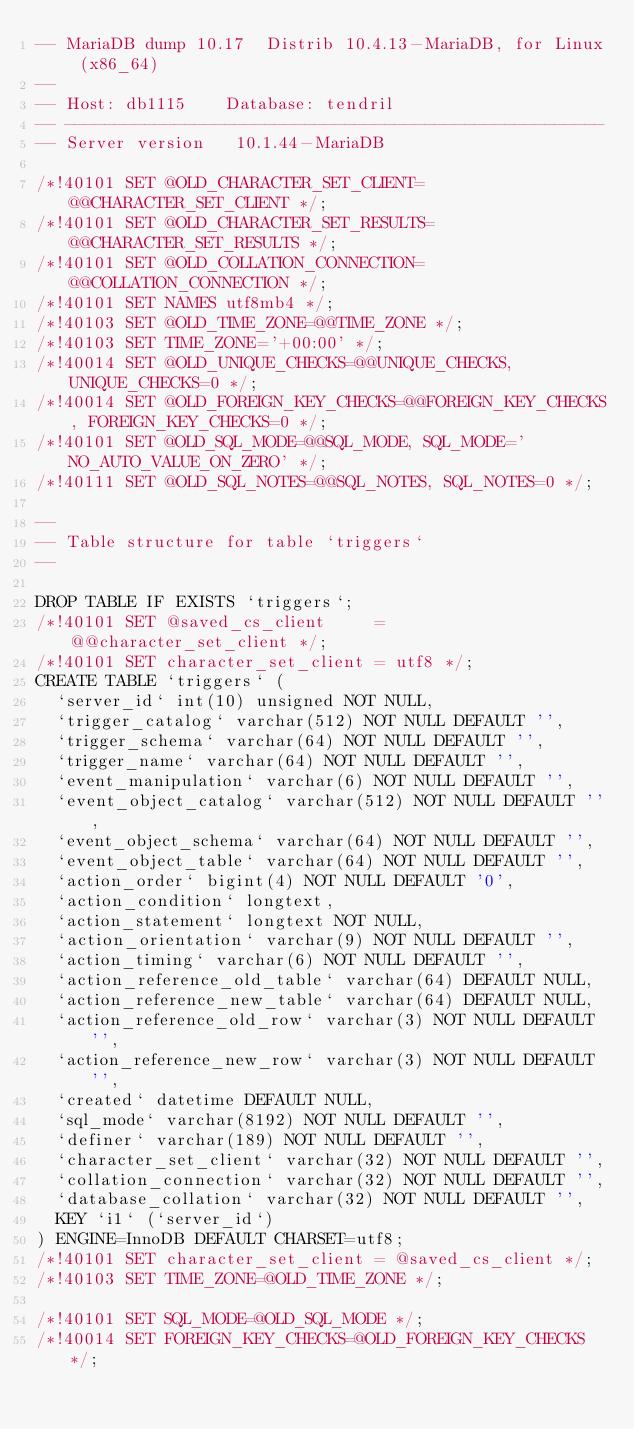Convert code to text. <code><loc_0><loc_0><loc_500><loc_500><_SQL_>-- MariaDB dump 10.17  Distrib 10.4.13-MariaDB, for Linux (x86_64)
--
-- Host: db1115    Database: tendril
-- ------------------------------------------------------
-- Server version	10.1.44-MariaDB

/*!40101 SET @OLD_CHARACTER_SET_CLIENT=@@CHARACTER_SET_CLIENT */;
/*!40101 SET @OLD_CHARACTER_SET_RESULTS=@@CHARACTER_SET_RESULTS */;
/*!40101 SET @OLD_COLLATION_CONNECTION=@@COLLATION_CONNECTION */;
/*!40101 SET NAMES utf8mb4 */;
/*!40103 SET @OLD_TIME_ZONE=@@TIME_ZONE */;
/*!40103 SET TIME_ZONE='+00:00' */;
/*!40014 SET @OLD_UNIQUE_CHECKS=@@UNIQUE_CHECKS, UNIQUE_CHECKS=0 */;
/*!40014 SET @OLD_FOREIGN_KEY_CHECKS=@@FOREIGN_KEY_CHECKS, FOREIGN_KEY_CHECKS=0 */;
/*!40101 SET @OLD_SQL_MODE=@@SQL_MODE, SQL_MODE='NO_AUTO_VALUE_ON_ZERO' */;
/*!40111 SET @OLD_SQL_NOTES=@@SQL_NOTES, SQL_NOTES=0 */;

--
-- Table structure for table `triggers`
--

DROP TABLE IF EXISTS `triggers`;
/*!40101 SET @saved_cs_client     = @@character_set_client */;
/*!40101 SET character_set_client = utf8 */;
CREATE TABLE `triggers` (
  `server_id` int(10) unsigned NOT NULL,
  `trigger_catalog` varchar(512) NOT NULL DEFAULT '',
  `trigger_schema` varchar(64) NOT NULL DEFAULT '',
  `trigger_name` varchar(64) NOT NULL DEFAULT '',
  `event_manipulation` varchar(6) NOT NULL DEFAULT '',
  `event_object_catalog` varchar(512) NOT NULL DEFAULT '',
  `event_object_schema` varchar(64) NOT NULL DEFAULT '',
  `event_object_table` varchar(64) NOT NULL DEFAULT '',
  `action_order` bigint(4) NOT NULL DEFAULT '0',
  `action_condition` longtext,
  `action_statement` longtext NOT NULL,
  `action_orientation` varchar(9) NOT NULL DEFAULT '',
  `action_timing` varchar(6) NOT NULL DEFAULT '',
  `action_reference_old_table` varchar(64) DEFAULT NULL,
  `action_reference_new_table` varchar(64) DEFAULT NULL,
  `action_reference_old_row` varchar(3) NOT NULL DEFAULT '',
  `action_reference_new_row` varchar(3) NOT NULL DEFAULT '',
  `created` datetime DEFAULT NULL,
  `sql_mode` varchar(8192) NOT NULL DEFAULT '',
  `definer` varchar(189) NOT NULL DEFAULT '',
  `character_set_client` varchar(32) NOT NULL DEFAULT '',
  `collation_connection` varchar(32) NOT NULL DEFAULT '',
  `database_collation` varchar(32) NOT NULL DEFAULT '',
  KEY `i1` (`server_id`)
) ENGINE=InnoDB DEFAULT CHARSET=utf8;
/*!40101 SET character_set_client = @saved_cs_client */;
/*!40103 SET TIME_ZONE=@OLD_TIME_ZONE */;

/*!40101 SET SQL_MODE=@OLD_SQL_MODE */;
/*!40014 SET FOREIGN_KEY_CHECKS=@OLD_FOREIGN_KEY_CHECKS */;</code> 